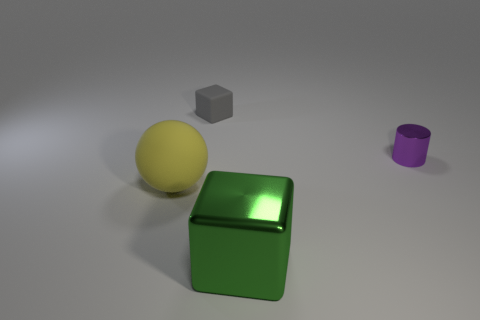Add 3 small blue things. How many objects exist? 7 Subtract all spheres. How many objects are left? 3 Add 2 small blue things. How many small blue things exist? 2 Subtract 0 cyan spheres. How many objects are left? 4 Subtract all green matte objects. Subtract all large blocks. How many objects are left? 3 Add 2 gray things. How many gray things are left? 3 